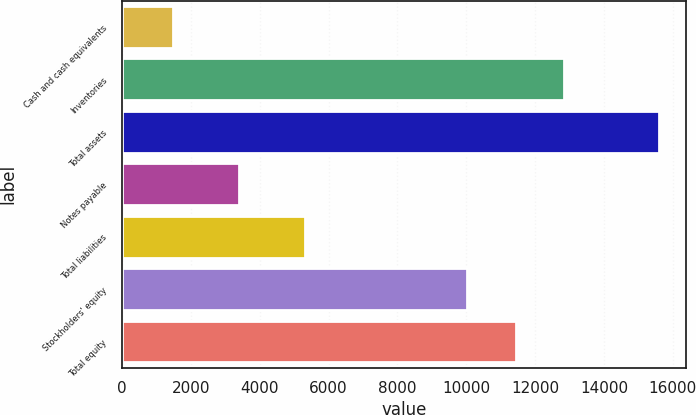Convert chart. <chart><loc_0><loc_0><loc_500><loc_500><bar_chart><fcel>Cash and cash equivalents<fcel>Inventories<fcel>Total assets<fcel>Notes payable<fcel>Total liabilities<fcel>Stockholders' equity<fcel>Total equity<nl><fcel>1494.3<fcel>12843.4<fcel>15606.6<fcel>3399.4<fcel>5311.5<fcel>10020.9<fcel>11432.1<nl></chart> 